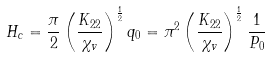<formula> <loc_0><loc_0><loc_500><loc_500>H _ { c } = \frac { \pi } { 2 } \left ( \frac { K _ { 2 2 } } { \chi _ { v } } \right ) ^ { \frac { 1 } { 2 } } q _ { 0 } = \pi ^ { 2 } \left ( \frac { K _ { 2 2 } } { \chi _ { v } } \right ) ^ { \frac { 1 } { 2 } } \frac { 1 } { P _ { 0 } }</formula> 